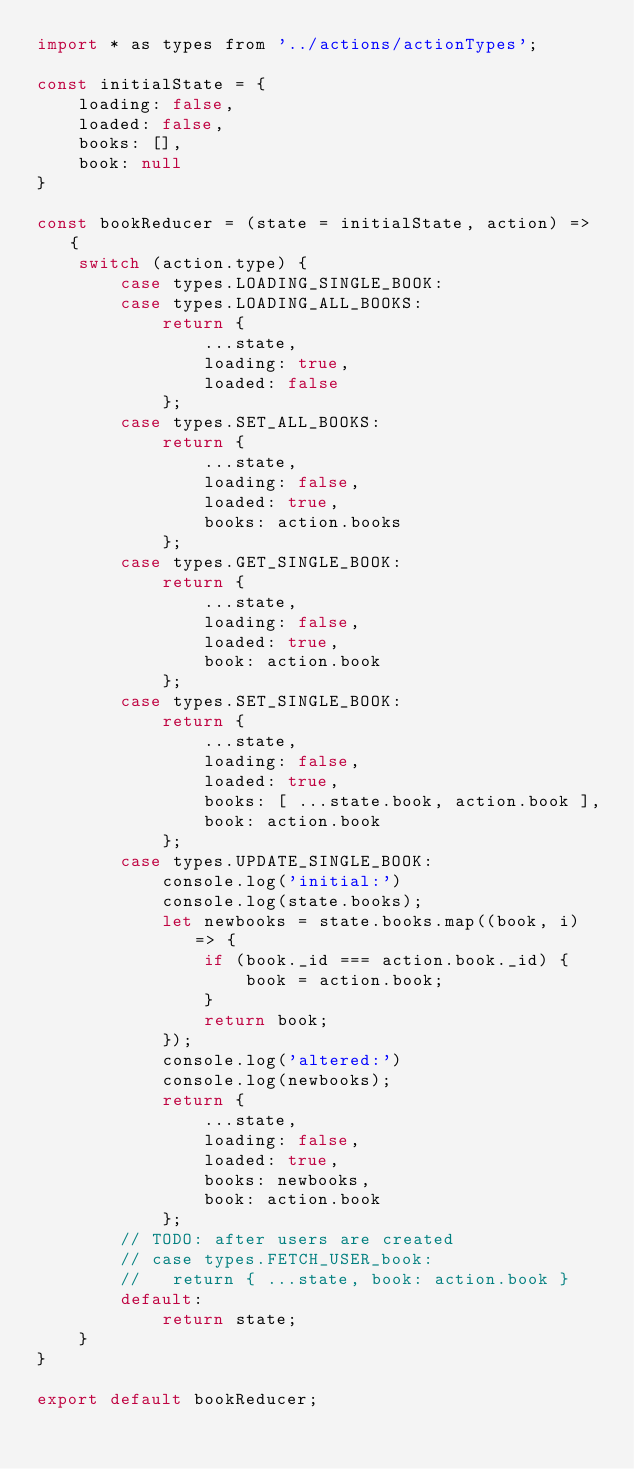Convert code to text. <code><loc_0><loc_0><loc_500><loc_500><_JavaScript_>import * as types from '../actions/actionTypes';

const initialState = {
    loading: false,
    loaded: false,
    books: [],
    book: null
}

const bookReducer = (state = initialState, action) => {
    switch (action.type) {
        case types.LOADING_SINGLE_BOOK:
        case types.LOADING_ALL_BOOKS:
            return {
                ...state,
                loading: true,
                loaded: false
            };
        case types.SET_ALL_BOOKS:
            return {
                ...state,
                loading: false,
                loaded: true,
                books: action.books
            };
        case types.GET_SINGLE_BOOK:
            return {
                ...state,
                loading: false,
                loaded: true,
                book: action.book
            };
        case types.SET_SINGLE_BOOK:
            return {
                ...state,
                loading: false,
                loaded: true,
                books: [ ...state.book, action.book ],
                book: action.book
            };
        case types.UPDATE_SINGLE_BOOK:
            console.log('initial:')
            console.log(state.books);
            let newbooks = state.books.map((book, i) => {
                if (book._id === action.book._id) {
                    book = action.book;
                }
                return book;
            });
            console.log('altered:')
            console.log(newbooks);
            return {
                ...state,
                loading: false,
                loaded: true,
                books: newbooks,
                book: action.book
            };
        // TODO: after users are created
        // case types.FETCH_USER_book:
        //   return { ...state, book: action.book }
        default:
            return state;
    }
}

export default bookReducer;
</code> 